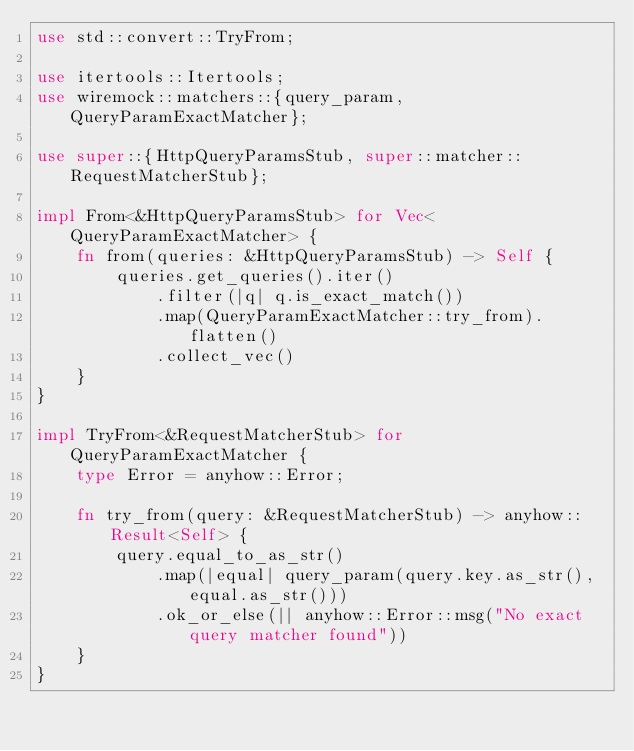Convert code to text. <code><loc_0><loc_0><loc_500><loc_500><_Rust_>use std::convert::TryFrom;

use itertools::Itertools;
use wiremock::matchers::{query_param, QueryParamExactMatcher};

use super::{HttpQueryParamsStub, super::matcher::RequestMatcherStub};

impl From<&HttpQueryParamsStub> for Vec<QueryParamExactMatcher> {
    fn from(queries: &HttpQueryParamsStub) -> Self {
        queries.get_queries().iter()
            .filter(|q| q.is_exact_match())
            .map(QueryParamExactMatcher::try_from).flatten()
            .collect_vec()
    }
}

impl TryFrom<&RequestMatcherStub> for QueryParamExactMatcher {
    type Error = anyhow::Error;

    fn try_from(query: &RequestMatcherStub) -> anyhow::Result<Self> {
        query.equal_to_as_str()
            .map(|equal| query_param(query.key.as_str(), equal.as_str()))
            .ok_or_else(|| anyhow::Error::msg("No exact query matcher found"))
    }
}</code> 